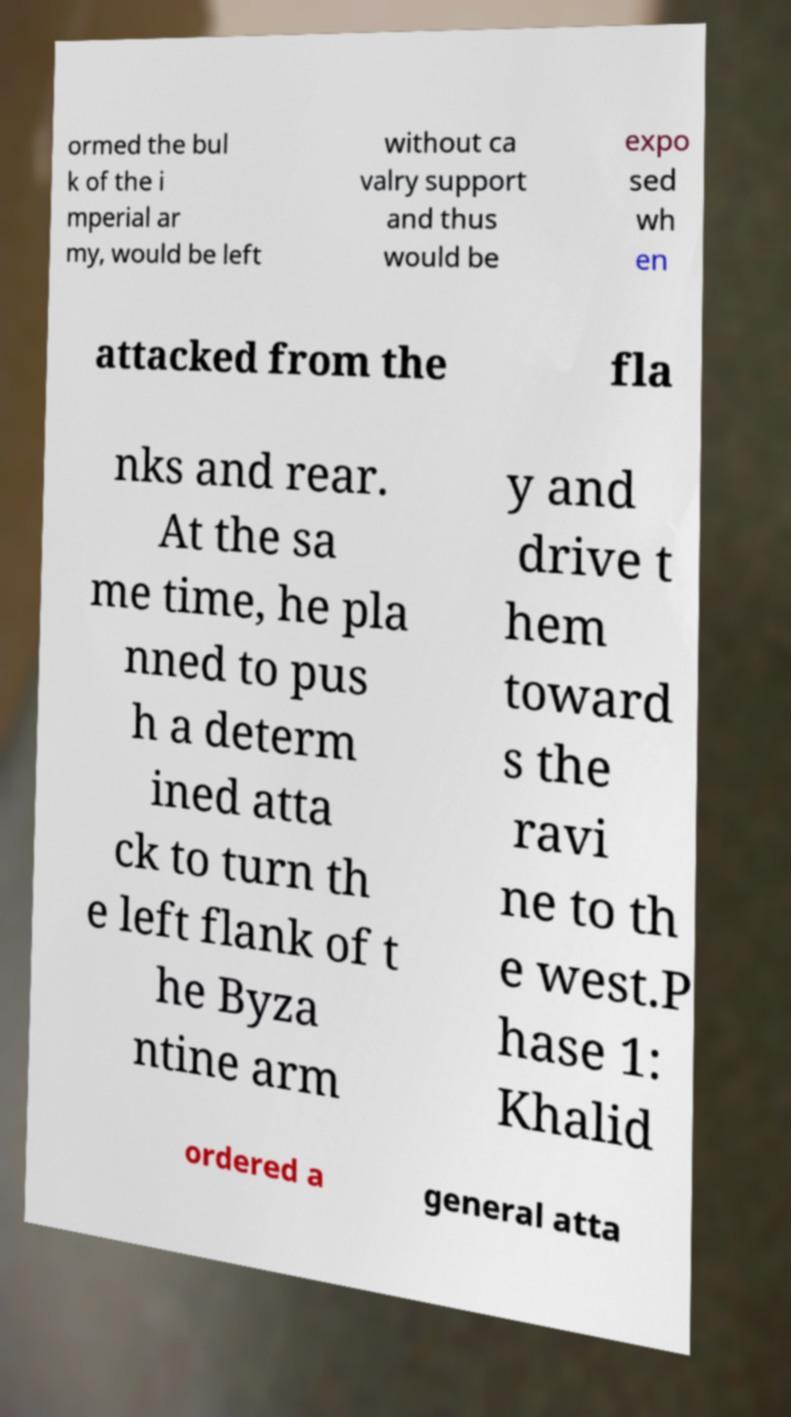For documentation purposes, I need the text within this image transcribed. Could you provide that? ormed the bul k of the i mperial ar my, would be left without ca valry support and thus would be expo sed wh en attacked from the fla nks and rear. At the sa me time, he pla nned to pus h a determ ined atta ck to turn th e left flank of t he Byza ntine arm y and drive t hem toward s the ravi ne to th e west.P hase 1: Khalid ordered a general atta 